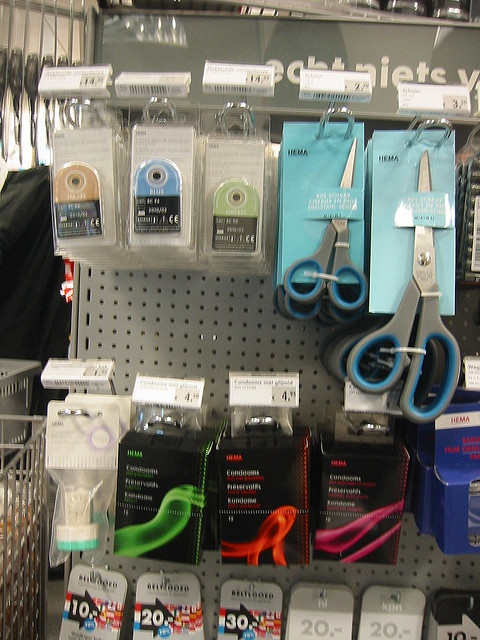Describe the objects in this image and their specific colors. I can see scissors in gray, black, and darkgray tones, scissors in gray, teal, black, and blue tones, scissors in gray, black, and darkblue tones, scissors in gray, black, and teal tones, and scissors in gray, black, and purple tones in this image. 